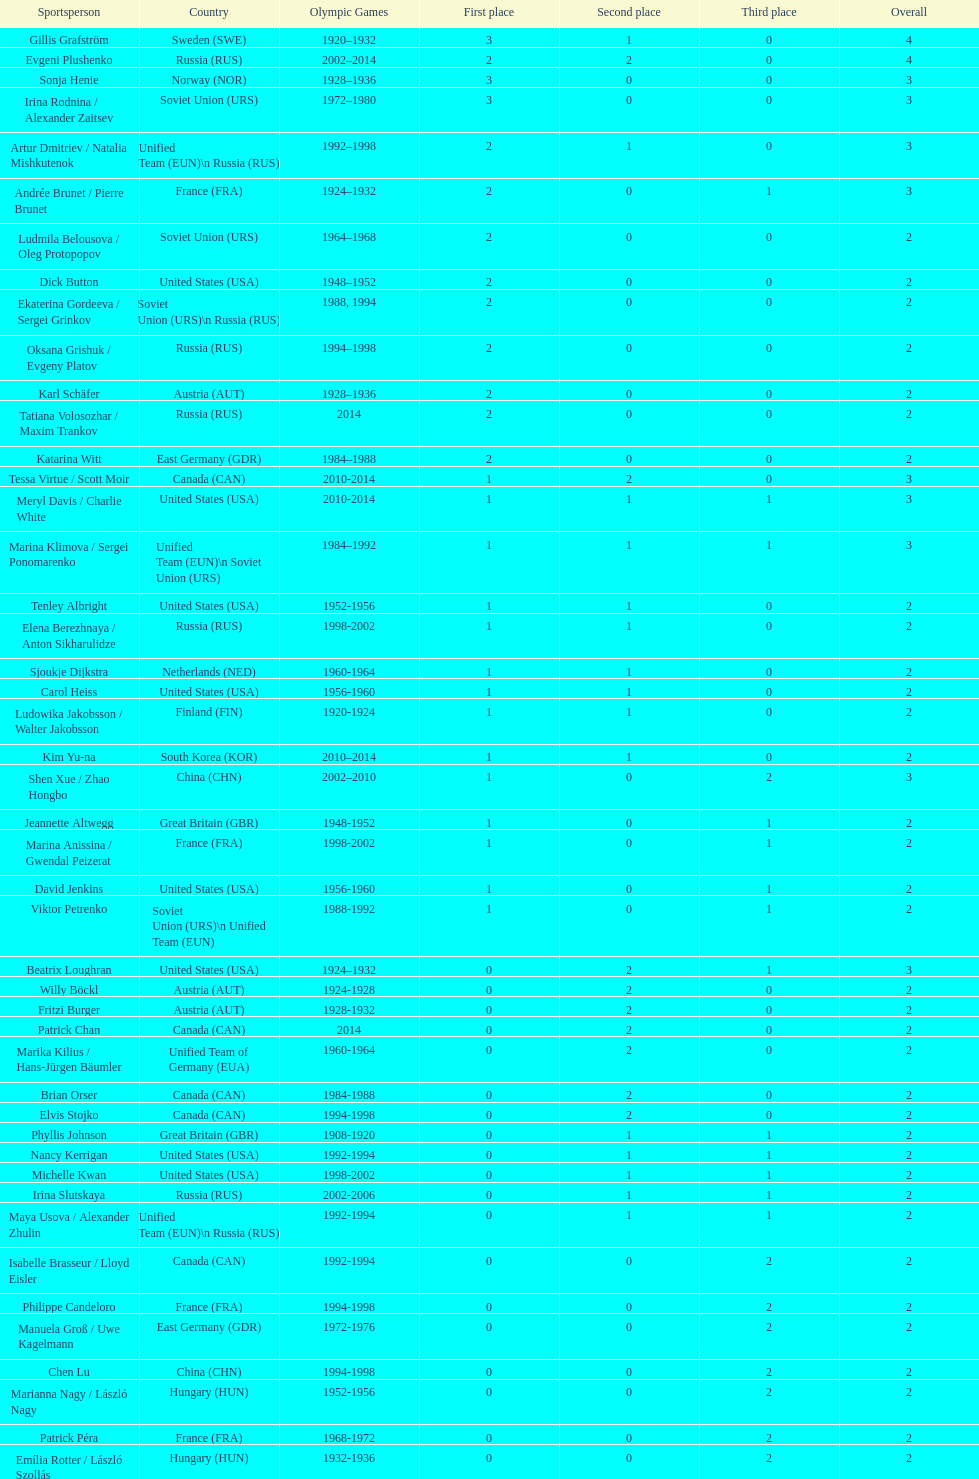How many total medals has the united states won in women's figure skating? 16. 